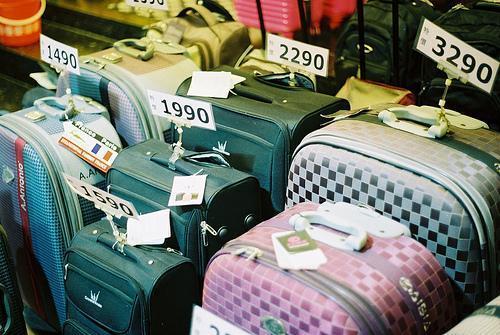How many of the bags are matching?
Give a very brief answer. 3. 